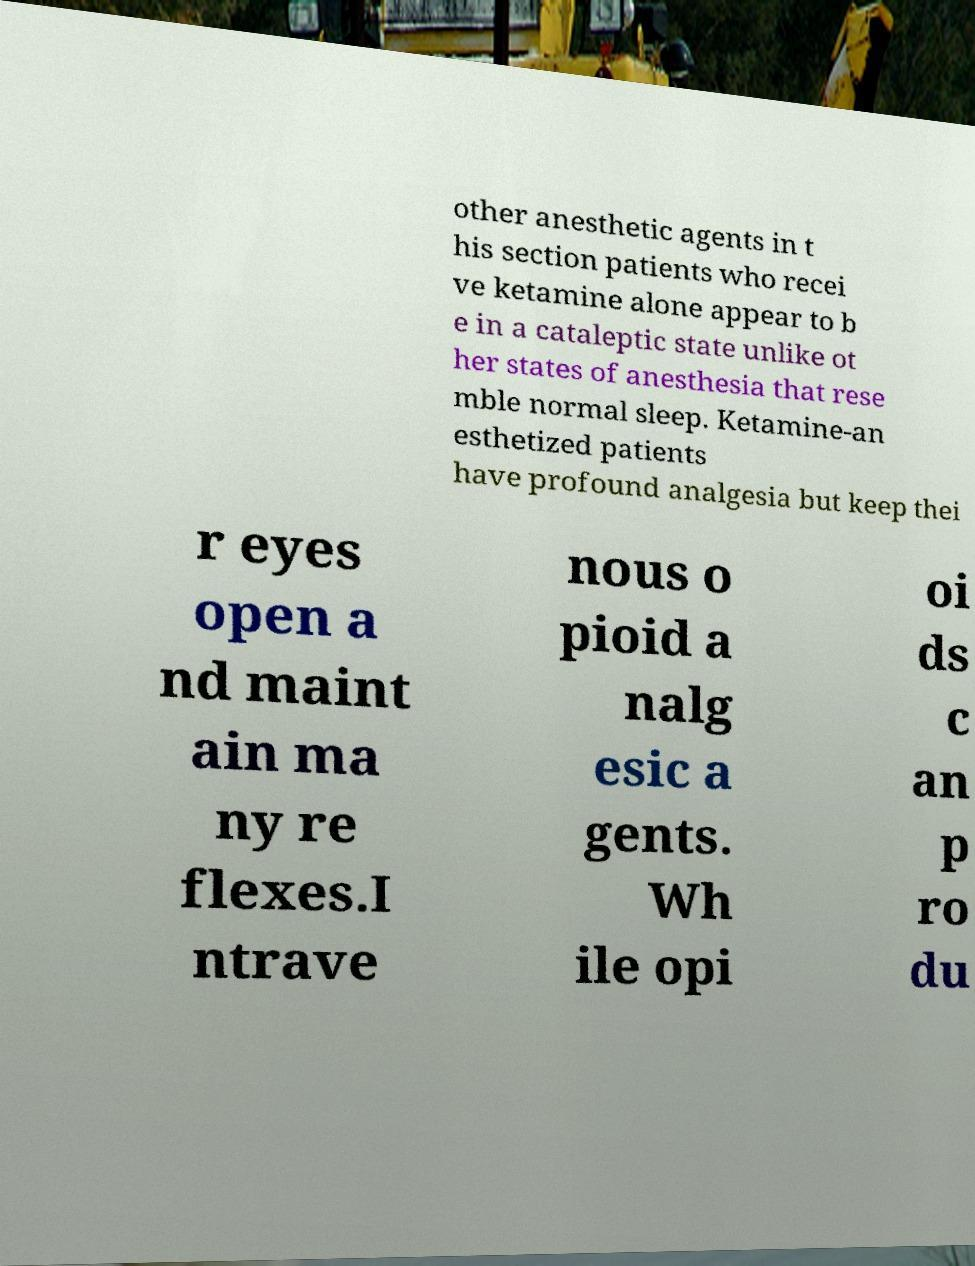What messages or text are displayed in this image? I need them in a readable, typed format. other anesthetic agents in t his section patients who recei ve ketamine alone appear to b e in a cataleptic state unlike ot her states of anesthesia that rese mble normal sleep. Ketamine-an esthetized patients have profound analgesia but keep thei r eyes open a nd maint ain ma ny re flexes.I ntrave nous o pioid a nalg esic a gents. Wh ile opi oi ds c an p ro du 